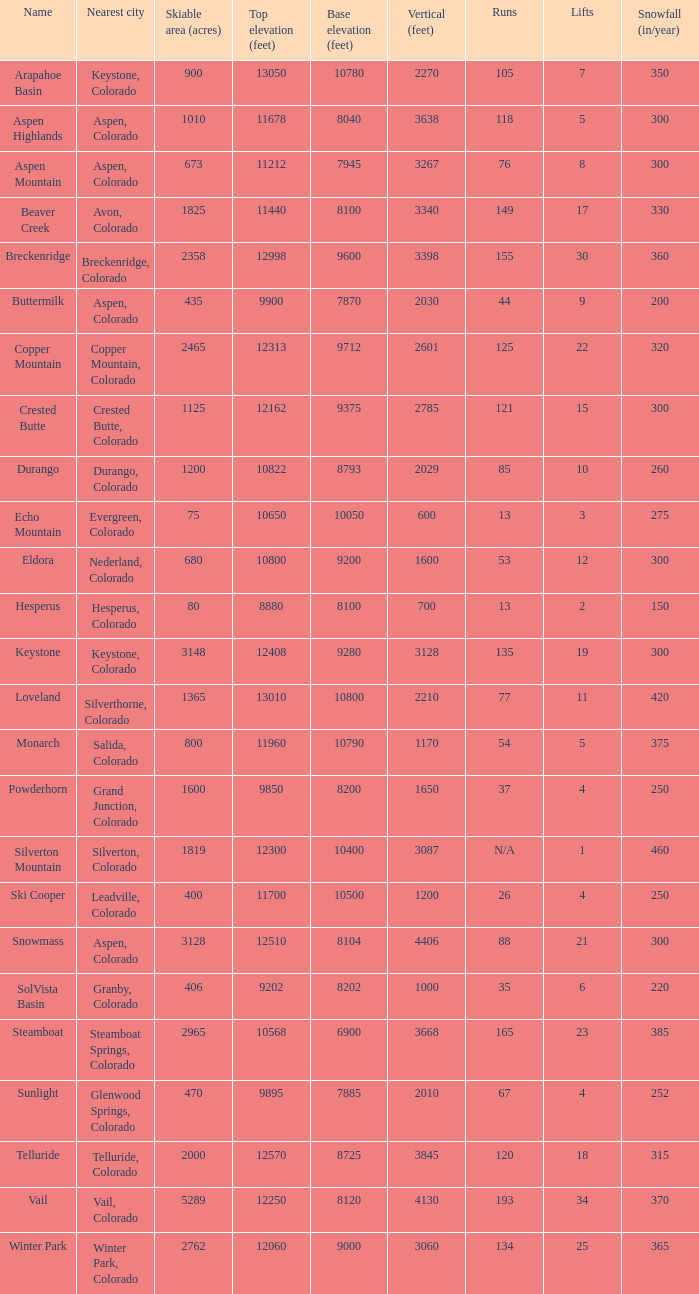If the name is Steamboat, what is the top elevation? 10568.0. Can you parse all the data within this table? {'header': ['Name', 'Nearest city', 'Skiable area (acres)', 'Top elevation (feet)', 'Base elevation (feet)', 'Vertical (feet)', 'Runs', 'Lifts', 'Snowfall (in/year)'], 'rows': [['Arapahoe Basin', 'Keystone, Colorado', '900', '13050', '10780', '2270', '105', '7', '350'], ['Aspen Highlands', 'Aspen, Colorado', '1010', '11678', '8040', '3638', '118', '5', '300'], ['Aspen Mountain', 'Aspen, Colorado', '673', '11212', '7945', '3267', '76', '8', '300'], ['Beaver Creek', 'Avon, Colorado', '1825', '11440', '8100', '3340', '149', '17', '330'], ['Breckenridge', 'Breckenridge, Colorado', '2358', '12998', '9600', '3398', '155', '30', '360'], ['Buttermilk', 'Aspen, Colorado', '435', '9900', '7870', '2030', '44', '9', '200'], ['Copper Mountain', 'Copper Mountain, Colorado', '2465', '12313', '9712', '2601', '125', '22', '320'], ['Crested Butte', 'Crested Butte, Colorado', '1125', '12162', '9375', '2785', '121', '15', '300'], ['Durango', 'Durango, Colorado', '1200', '10822', '8793', '2029', '85', '10', '260'], ['Echo Mountain', 'Evergreen, Colorado', '75', '10650', '10050', '600', '13', '3', '275'], ['Eldora', 'Nederland, Colorado', '680', '10800', '9200', '1600', '53', '12', '300'], ['Hesperus', 'Hesperus, Colorado', '80', '8880', '8100', '700', '13', '2', '150'], ['Keystone', 'Keystone, Colorado', '3148', '12408', '9280', '3128', '135', '19', '300'], ['Loveland', 'Silverthorne, Colorado', '1365', '13010', '10800', '2210', '77', '11', '420'], ['Monarch', 'Salida, Colorado', '800', '11960', '10790', '1170', '54', '5', '375'], ['Powderhorn', 'Grand Junction, Colorado', '1600', '9850', '8200', '1650', '37', '4', '250'], ['Silverton Mountain', 'Silverton, Colorado', '1819', '12300', '10400', '3087', 'N/A', '1', '460'], ['Ski Cooper', 'Leadville, Colorado', '400', '11700', '10500', '1200', '26', '4', '250'], ['Snowmass', 'Aspen, Colorado', '3128', '12510', '8104', '4406', '88', '21', '300'], ['SolVista Basin', 'Granby, Colorado', '406', '9202', '8202', '1000', '35', '6', '220'], ['Steamboat', 'Steamboat Springs, Colorado', '2965', '10568', '6900', '3668', '165', '23', '385'], ['Sunlight', 'Glenwood Springs, Colorado', '470', '9895', '7885', '2010', '67', '4', '252'], ['Telluride', 'Telluride, Colorado', '2000', '12570', '8725', '3845', '120', '18', '315'], ['Vail', 'Vail, Colorado', '5289', '12250', '8120', '4130', '193', '34', '370'], ['Winter Park', 'Winter Park, Colorado', '2762', '12060', '9000', '3060', '134', '25', '365']]} 